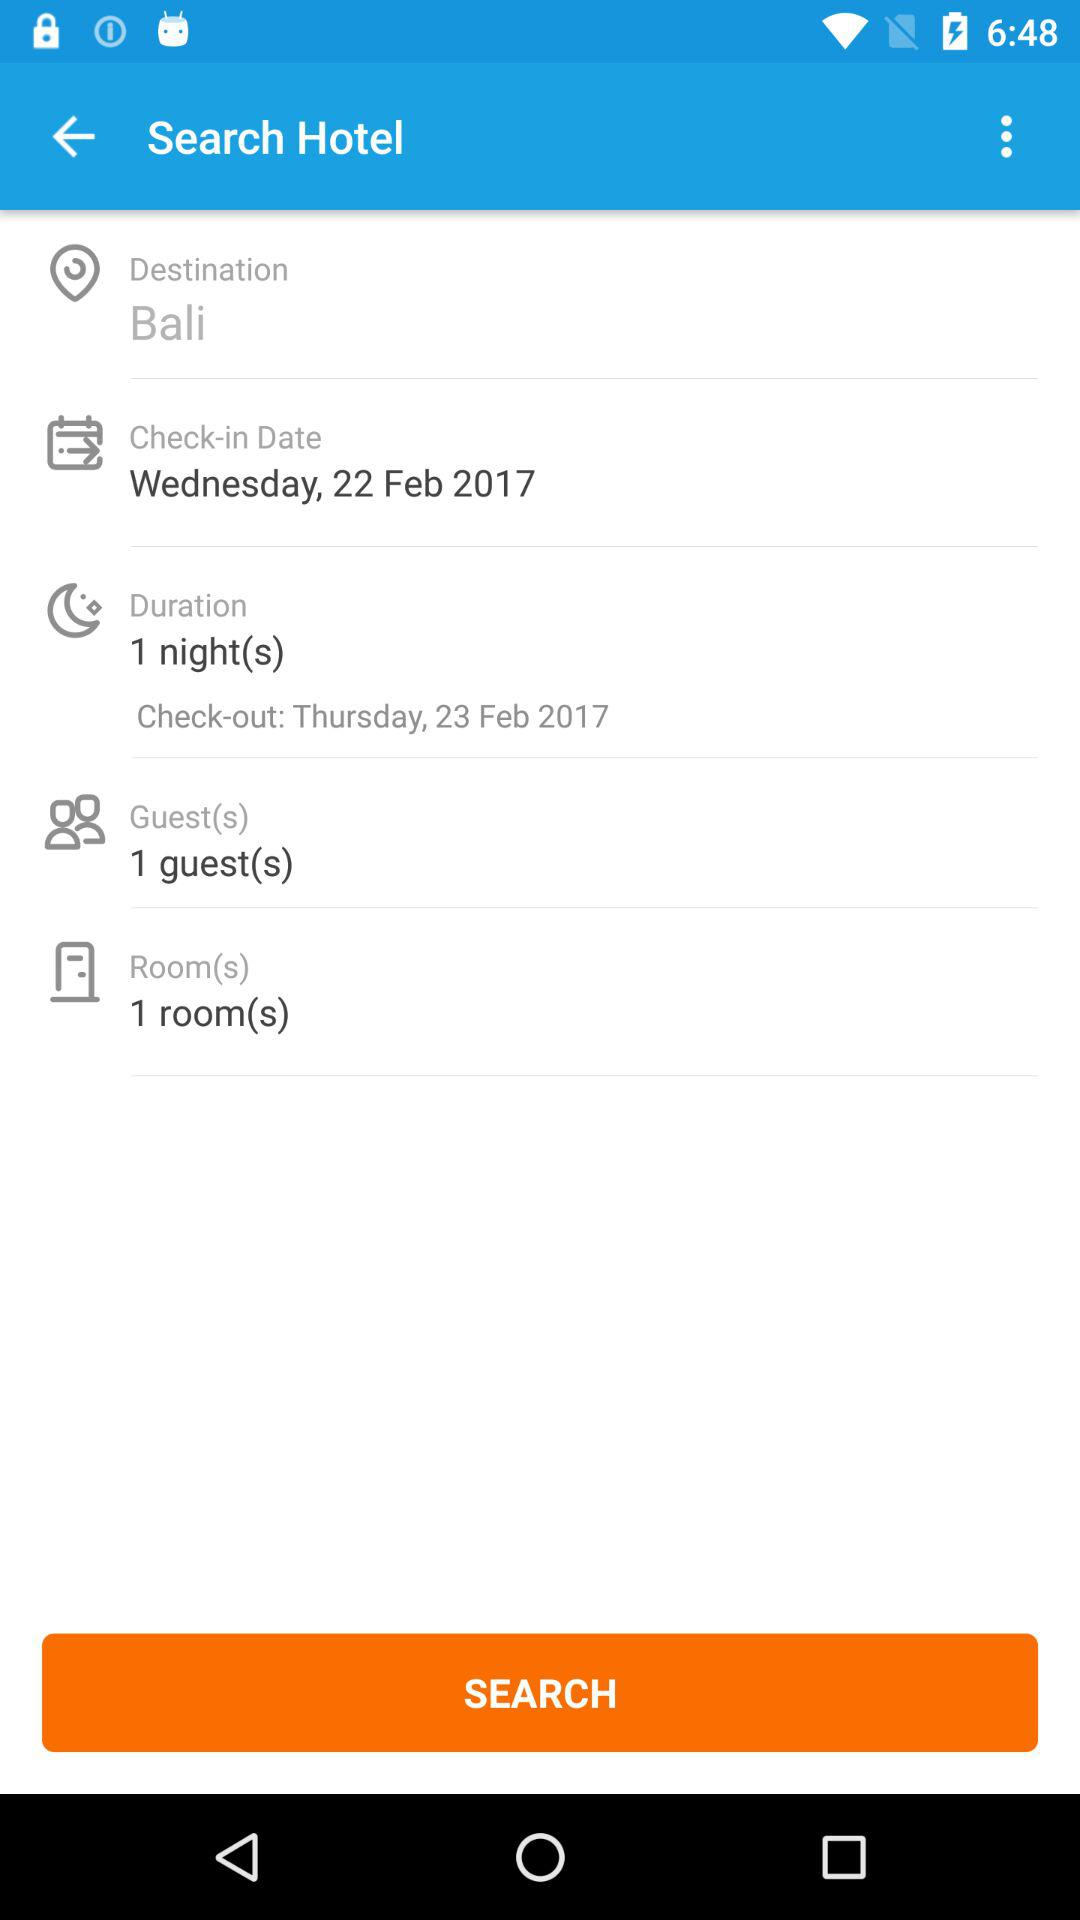How many rooms are selected? There is 1 selected room. 